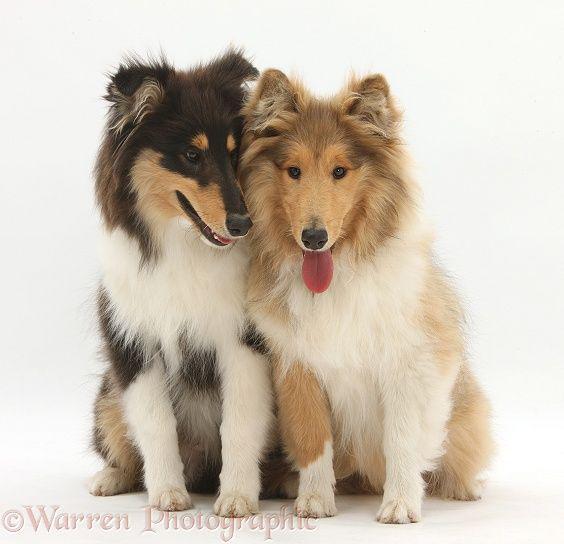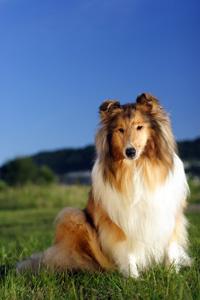The first image is the image on the left, the second image is the image on the right. Evaluate the accuracy of this statement regarding the images: "There are no more than three dogs.". Is it true? Answer yes or no. Yes. The first image is the image on the left, the second image is the image on the right. For the images shown, is this caption "There are at most three dogs." true? Answer yes or no. Yes. 